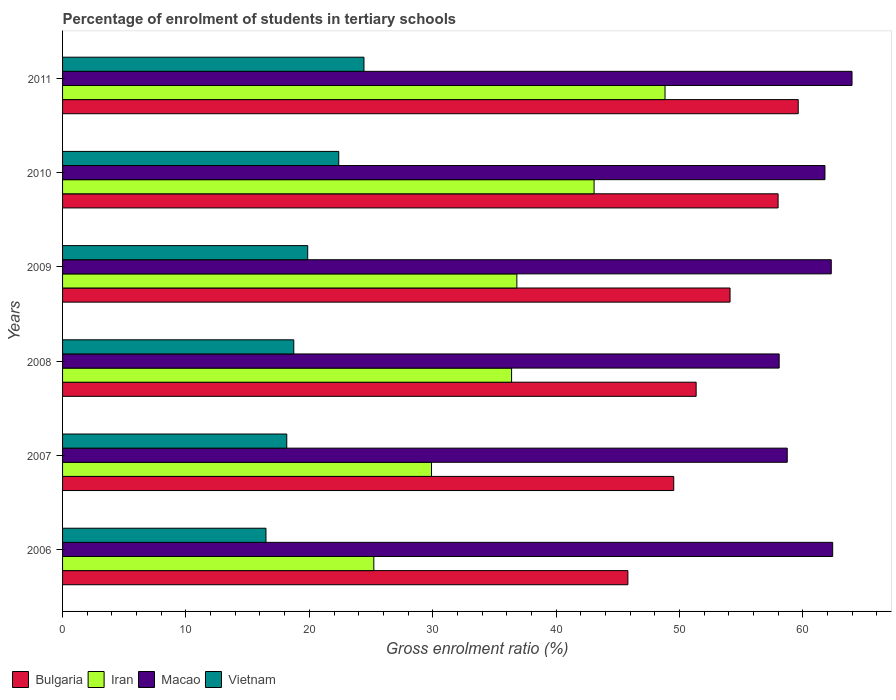How many groups of bars are there?
Provide a short and direct response. 6. Are the number of bars per tick equal to the number of legend labels?
Offer a terse response. Yes. Are the number of bars on each tick of the Y-axis equal?
Your answer should be very brief. Yes. What is the percentage of students enrolled in tertiary schools in Bulgaria in 2011?
Provide a succinct answer. 59.63. Across all years, what is the maximum percentage of students enrolled in tertiary schools in Macao?
Provide a short and direct response. 63.99. Across all years, what is the minimum percentage of students enrolled in tertiary schools in Vietnam?
Make the answer very short. 16.49. What is the total percentage of students enrolled in tertiary schools in Bulgaria in the graph?
Keep it short and to the point. 318.42. What is the difference between the percentage of students enrolled in tertiary schools in Bulgaria in 2006 and that in 2007?
Offer a very short reply. -3.72. What is the difference between the percentage of students enrolled in tertiary schools in Bulgaria in 2008 and the percentage of students enrolled in tertiary schools in Vietnam in 2007?
Your answer should be very brief. 33.18. What is the average percentage of students enrolled in tertiary schools in Bulgaria per year?
Your answer should be compact. 53.07. In the year 2011, what is the difference between the percentage of students enrolled in tertiary schools in Iran and percentage of students enrolled in tertiary schools in Bulgaria?
Ensure brevity in your answer.  -10.8. What is the ratio of the percentage of students enrolled in tertiary schools in Vietnam in 2010 to that in 2011?
Your answer should be very brief. 0.92. What is the difference between the highest and the second highest percentage of students enrolled in tertiary schools in Iran?
Ensure brevity in your answer.  5.75. What is the difference between the highest and the lowest percentage of students enrolled in tertiary schools in Bulgaria?
Offer a very short reply. 13.81. In how many years, is the percentage of students enrolled in tertiary schools in Macao greater than the average percentage of students enrolled in tertiary schools in Macao taken over all years?
Ensure brevity in your answer.  4. Is the sum of the percentage of students enrolled in tertiary schools in Iran in 2008 and 2010 greater than the maximum percentage of students enrolled in tertiary schools in Macao across all years?
Your answer should be very brief. Yes. Is it the case that in every year, the sum of the percentage of students enrolled in tertiary schools in Macao and percentage of students enrolled in tertiary schools in Iran is greater than the sum of percentage of students enrolled in tertiary schools in Vietnam and percentage of students enrolled in tertiary schools in Bulgaria?
Your response must be concise. No. What does the 2nd bar from the top in 2007 represents?
Your answer should be very brief. Macao. What does the 3rd bar from the bottom in 2009 represents?
Your answer should be very brief. Macao. Is it the case that in every year, the sum of the percentage of students enrolled in tertiary schools in Macao and percentage of students enrolled in tertiary schools in Iran is greater than the percentage of students enrolled in tertiary schools in Bulgaria?
Your response must be concise. Yes. Are the values on the major ticks of X-axis written in scientific E-notation?
Provide a succinct answer. No. Does the graph contain grids?
Your response must be concise. No. How many legend labels are there?
Make the answer very short. 4. What is the title of the graph?
Provide a succinct answer. Percentage of enrolment of students in tertiary schools. Does "North America" appear as one of the legend labels in the graph?
Give a very brief answer. No. What is the label or title of the X-axis?
Your response must be concise. Gross enrolment ratio (%). What is the Gross enrolment ratio (%) in Bulgaria in 2006?
Your response must be concise. 45.82. What is the Gross enrolment ratio (%) of Iran in 2006?
Give a very brief answer. 25.23. What is the Gross enrolment ratio (%) of Macao in 2006?
Your answer should be compact. 62.42. What is the Gross enrolment ratio (%) in Vietnam in 2006?
Your response must be concise. 16.49. What is the Gross enrolment ratio (%) in Bulgaria in 2007?
Ensure brevity in your answer.  49.53. What is the Gross enrolment ratio (%) of Iran in 2007?
Make the answer very short. 29.9. What is the Gross enrolment ratio (%) in Macao in 2007?
Your answer should be very brief. 58.73. What is the Gross enrolment ratio (%) of Vietnam in 2007?
Your response must be concise. 18.17. What is the Gross enrolment ratio (%) of Bulgaria in 2008?
Provide a succinct answer. 51.35. What is the Gross enrolment ratio (%) in Iran in 2008?
Offer a very short reply. 36.39. What is the Gross enrolment ratio (%) in Macao in 2008?
Your response must be concise. 58.08. What is the Gross enrolment ratio (%) in Vietnam in 2008?
Your answer should be very brief. 18.74. What is the Gross enrolment ratio (%) in Bulgaria in 2009?
Offer a very short reply. 54.1. What is the Gross enrolment ratio (%) in Iran in 2009?
Provide a short and direct response. 36.82. What is the Gross enrolment ratio (%) of Macao in 2009?
Your answer should be very brief. 62.3. What is the Gross enrolment ratio (%) in Vietnam in 2009?
Your answer should be very brief. 19.87. What is the Gross enrolment ratio (%) in Bulgaria in 2010?
Ensure brevity in your answer.  57.99. What is the Gross enrolment ratio (%) of Iran in 2010?
Make the answer very short. 43.08. What is the Gross enrolment ratio (%) in Macao in 2010?
Make the answer very short. 61.79. What is the Gross enrolment ratio (%) of Vietnam in 2010?
Offer a very short reply. 22.39. What is the Gross enrolment ratio (%) of Bulgaria in 2011?
Provide a short and direct response. 59.63. What is the Gross enrolment ratio (%) of Iran in 2011?
Your answer should be very brief. 48.83. What is the Gross enrolment ratio (%) of Macao in 2011?
Provide a succinct answer. 63.99. What is the Gross enrolment ratio (%) of Vietnam in 2011?
Your response must be concise. 24.43. Across all years, what is the maximum Gross enrolment ratio (%) in Bulgaria?
Offer a very short reply. 59.63. Across all years, what is the maximum Gross enrolment ratio (%) of Iran?
Offer a very short reply. 48.83. Across all years, what is the maximum Gross enrolment ratio (%) of Macao?
Offer a very short reply. 63.99. Across all years, what is the maximum Gross enrolment ratio (%) of Vietnam?
Provide a succinct answer. 24.43. Across all years, what is the minimum Gross enrolment ratio (%) of Bulgaria?
Your response must be concise. 45.82. Across all years, what is the minimum Gross enrolment ratio (%) of Iran?
Make the answer very short. 25.23. Across all years, what is the minimum Gross enrolment ratio (%) of Macao?
Give a very brief answer. 58.08. Across all years, what is the minimum Gross enrolment ratio (%) of Vietnam?
Provide a short and direct response. 16.49. What is the total Gross enrolment ratio (%) of Bulgaria in the graph?
Give a very brief answer. 318.42. What is the total Gross enrolment ratio (%) in Iran in the graph?
Keep it short and to the point. 220.26. What is the total Gross enrolment ratio (%) of Macao in the graph?
Give a very brief answer. 367.31. What is the total Gross enrolment ratio (%) of Vietnam in the graph?
Your answer should be compact. 120.08. What is the difference between the Gross enrolment ratio (%) in Bulgaria in 2006 and that in 2007?
Offer a terse response. -3.72. What is the difference between the Gross enrolment ratio (%) of Iran in 2006 and that in 2007?
Your answer should be very brief. -4.67. What is the difference between the Gross enrolment ratio (%) in Macao in 2006 and that in 2007?
Your response must be concise. 3.68. What is the difference between the Gross enrolment ratio (%) in Vietnam in 2006 and that in 2007?
Make the answer very short. -1.69. What is the difference between the Gross enrolment ratio (%) of Bulgaria in 2006 and that in 2008?
Keep it short and to the point. -5.53. What is the difference between the Gross enrolment ratio (%) in Iran in 2006 and that in 2008?
Offer a very short reply. -11.17. What is the difference between the Gross enrolment ratio (%) in Macao in 2006 and that in 2008?
Provide a short and direct response. 4.34. What is the difference between the Gross enrolment ratio (%) in Vietnam in 2006 and that in 2008?
Provide a succinct answer. -2.26. What is the difference between the Gross enrolment ratio (%) in Bulgaria in 2006 and that in 2009?
Provide a succinct answer. -8.28. What is the difference between the Gross enrolment ratio (%) of Iran in 2006 and that in 2009?
Offer a terse response. -11.59. What is the difference between the Gross enrolment ratio (%) in Macao in 2006 and that in 2009?
Ensure brevity in your answer.  0.11. What is the difference between the Gross enrolment ratio (%) of Vietnam in 2006 and that in 2009?
Provide a short and direct response. -3.38. What is the difference between the Gross enrolment ratio (%) in Bulgaria in 2006 and that in 2010?
Offer a very short reply. -12.17. What is the difference between the Gross enrolment ratio (%) of Iran in 2006 and that in 2010?
Ensure brevity in your answer.  -17.85. What is the difference between the Gross enrolment ratio (%) of Macao in 2006 and that in 2010?
Offer a very short reply. 0.63. What is the difference between the Gross enrolment ratio (%) of Vietnam in 2006 and that in 2010?
Your answer should be very brief. -5.9. What is the difference between the Gross enrolment ratio (%) in Bulgaria in 2006 and that in 2011?
Provide a short and direct response. -13.81. What is the difference between the Gross enrolment ratio (%) of Iran in 2006 and that in 2011?
Provide a succinct answer. -23.6. What is the difference between the Gross enrolment ratio (%) in Macao in 2006 and that in 2011?
Give a very brief answer. -1.57. What is the difference between the Gross enrolment ratio (%) of Vietnam in 2006 and that in 2011?
Offer a very short reply. -7.94. What is the difference between the Gross enrolment ratio (%) of Bulgaria in 2007 and that in 2008?
Offer a terse response. -1.82. What is the difference between the Gross enrolment ratio (%) of Iran in 2007 and that in 2008?
Ensure brevity in your answer.  -6.49. What is the difference between the Gross enrolment ratio (%) of Macao in 2007 and that in 2008?
Ensure brevity in your answer.  0.65. What is the difference between the Gross enrolment ratio (%) of Vietnam in 2007 and that in 2008?
Give a very brief answer. -0.57. What is the difference between the Gross enrolment ratio (%) of Bulgaria in 2007 and that in 2009?
Your response must be concise. -4.56. What is the difference between the Gross enrolment ratio (%) in Iran in 2007 and that in 2009?
Ensure brevity in your answer.  -6.92. What is the difference between the Gross enrolment ratio (%) of Macao in 2007 and that in 2009?
Offer a very short reply. -3.57. What is the difference between the Gross enrolment ratio (%) of Vietnam in 2007 and that in 2009?
Offer a terse response. -1.7. What is the difference between the Gross enrolment ratio (%) in Bulgaria in 2007 and that in 2010?
Offer a very short reply. -8.46. What is the difference between the Gross enrolment ratio (%) in Iran in 2007 and that in 2010?
Provide a succinct answer. -13.18. What is the difference between the Gross enrolment ratio (%) of Macao in 2007 and that in 2010?
Give a very brief answer. -3.06. What is the difference between the Gross enrolment ratio (%) in Vietnam in 2007 and that in 2010?
Keep it short and to the point. -4.21. What is the difference between the Gross enrolment ratio (%) of Bulgaria in 2007 and that in 2011?
Provide a short and direct response. -10.09. What is the difference between the Gross enrolment ratio (%) in Iran in 2007 and that in 2011?
Give a very brief answer. -18.93. What is the difference between the Gross enrolment ratio (%) of Macao in 2007 and that in 2011?
Provide a succinct answer. -5.25. What is the difference between the Gross enrolment ratio (%) of Vietnam in 2007 and that in 2011?
Make the answer very short. -6.26. What is the difference between the Gross enrolment ratio (%) of Bulgaria in 2008 and that in 2009?
Make the answer very short. -2.75. What is the difference between the Gross enrolment ratio (%) of Iran in 2008 and that in 2009?
Provide a succinct answer. -0.43. What is the difference between the Gross enrolment ratio (%) in Macao in 2008 and that in 2009?
Your answer should be very brief. -4.22. What is the difference between the Gross enrolment ratio (%) in Vietnam in 2008 and that in 2009?
Your answer should be very brief. -1.13. What is the difference between the Gross enrolment ratio (%) in Bulgaria in 2008 and that in 2010?
Provide a short and direct response. -6.64. What is the difference between the Gross enrolment ratio (%) in Iran in 2008 and that in 2010?
Provide a succinct answer. -6.69. What is the difference between the Gross enrolment ratio (%) of Macao in 2008 and that in 2010?
Your answer should be very brief. -3.71. What is the difference between the Gross enrolment ratio (%) of Vietnam in 2008 and that in 2010?
Make the answer very short. -3.64. What is the difference between the Gross enrolment ratio (%) of Bulgaria in 2008 and that in 2011?
Give a very brief answer. -8.27. What is the difference between the Gross enrolment ratio (%) in Iran in 2008 and that in 2011?
Give a very brief answer. -12.44. What is the difference between the Gross enrolment ratio (%) of Macao in 2008 and that in 2011?
Provide a short and direct response. -5.9. What is the difference between the Gross enrolment ratio (%) in Vietnam in 2008 and that in 2011?
Make the answer very short. -5.69. What is the difference between the Gross enrolment ratio (%) of Bulgaria in 2009 and that in 2010?
Provide a short and direct response. -3.89. What is the difference between the Gross enrolment ratio (%) in Iran in 2009 and that in 2010?
Your answer should be compact. -6.26. What is the difference between the Gross enrolment ratio (%) in Macao in 2009 and that in 2010?
Provide a succinct answer. 0.51. What is the difference between the Gross enrolment ratio (%) in Vietnam in 2009 and that in 2010?
Provide a succinct answer. -2.52. What is the difference between the Gross enrolment ratio (%) of Bulgaria in 2009 and that in 2011?
Offer a very short reply. -5.53. What is the difference between the Gross enrolment ratio (%) of Iran in 2009 and that in 2011?
Offer a terse response. -12.01. What is the difference between the Gross enrolment ratio (%) in Macao in 2009 and that in 2011?
Your answer should be compact. -1.68. What is the difference between the Gross enrolment ratio (%) of Vietnam in 2009 and that in 2011?
Keep it short and to the point. -4.56. What is the difference between the Gross enrolment ratio (%) of Bulgaria in 2010 and that in 2011?
Give a very brief answer. -1.63. What is the difference between the Gross enrolment ratio (%) of Iran in 2010 and that in 2011?
Offer a terse response. -5.75. What is the difference between the Gross enrolment ratio (%) in Macao in 2010 and that in 2011?
Your answer should be very brief. -2.19. What is the difference between the Gross enrolment ratio (%) of Vietnam in 2010 and that in 2011?
Ensure brevity in your answer.  -2.04. What is the difference between the Gross enrolment ratio (%) in Bulgaria in 2006 and the Gross enrolment ratio (%) in Iran in 2007?
Your answer should be very brief. 15.92. What is the difference between the Gross enrolment ratio (%) of Bulgaria in 2006 and the Gross enrolment ratio (%) of Macao in 2007?
Your answer should be very brief. -12.91. What is the difference between the Gross enrolment ratio (%) in Bulgaria in 2006 and the Gross enrolment ratio (%) in Vietnam in 2007?
Keep it short and to the point. 27.65. What is the difference between the Gross enrolment ratio (%) of Iran in 2006 and the Gross enrolment ratio (%) of Macao in 2007?
Ensure brevity in your answer.  -33.51. What is the difference between the Gross enrolment ratio (%) in Iran in 2006 and the Gross enrolment ratio (%) in Vietnam in 2007?
Provide a short and direct response. 7.06. What is the difference between the Gross enrolment ratio (%) in Macao in 2006 and the Gross enrolment ratio (%) in Vietnam in 2007?
Keep it short and to the point. 44.25. What is the difference between the Gross enrolment ratio (%) in Bulgaria in 2006 and the Gross enrolment ratio (%) in Iran in 2008?
Ensure brevity in your answer.  9.43. What is the difference between the Gross enrolment ratio (%) of Bulgaria in 2006 and the Gross enrolment ratio (%) of Macao in 2008?
Keep it short and to the point. -12.26. What is the difference between the Gross enrolment ratio (%) of Bulgaria in 2006 and the Gross enrolment ratio (%) of Vietnam in 2008?
Keep it short and to the point. 27.08. What is the difference between the Gross enrolment ratio (%) of Iran in 2006 and the Gross enrolment ratio (%) of Macao in 2008?
Provide a succinct answer. -32.85. What is the difference between the Gross enrolment ratio (%) of Iran in 2006 and the Gross enrolment ratio (%) of Vietnam in 2008?
Offer a very short reply. 6.49. What is the difference between the Gross enrolment ratio (%) in Macao in 2006 and the Gross enrolment ratio (%) in Vietnam in 2008?
Provide a succinct answer. 43.68. What is the difference between the Gross enrolment ratio (%) of Bulgaria in 2006 and the Gross enrolment ratio (%) of Iran in 2009?
Offer a terse response. 9. What is the difference between the Gross enrolment ratio (%) of Bulgaria in 2006 and the Gross enrolment ratio (%) of Macao in 2009?
Your answer should be very brief. -16.48. What is the difference between the Gross enrolment ratio (%) in Bulgaria in 2006 and the Gross enrolment ratio (%) in Vietnam in 2009?
Provide a succinct answer. 25.95. What is the difference between the Gross enrolment ratio (%) of Iran in 2006 and the Gross enrolment ratio (%) of Macao in 2009?
Keep it short and to the point. -37.07. What is the difference between the Gross enrolment ratio (%) of Iran in 2006 and the Gross enrolment ratio (%) of Vietnam in 2009?
Ensure brevity in your answer.  5.36. What is the difference between the Gross enrolment ratio (%) of Macao in 2006 and the Gross enrolment ratio (%) of Vietnam in 2009?
Ensure brevity in your answer.  42.55. What is the difference between the Gross enrolment ratio (%) of Bulgaria in 2006 and the Gross enrolment ratio (%) of Iran in 2010?
Your answer should be very brief. 2.74. What is the difference between the Gross enrolment ratio (%) of Bulgaria in 2006 and the Gross enrolment ratio (%) of Macao in 2010?
Your response must be concise. -15.97. What is the difference between the Gross enrolment ratio (%) of Bulgaria in 2006 and the Gross enrolment ratio (%) of Vietnam in 2010?
Ensure brevity in your answer.  23.43. What is the difference between the Gross enrolment ratio (%) in Iran in 2006 and the Gross enrolment ratio (%) in Macao in 2010?
Offer a very short reply. -36.56. What is the difference between the Gross enrolment ratio (%) of Iran in 2006 and the Gross enrolment ratio (%) of Vietnam in 2010?
Offer a terse response. 2.84. What is the difference between the Gross enrolment ratio (%) in Macao in 2006 and the Gross enrolment ratio (%) in Vietnam in 2010?
Provide a short and direct response. 40.03. What is the difference between the Gross enrolment ratio (%) in Bulgaria in 2006 and the Gross enrolment ratio (%) in Iran in 2011?
Ensure brevity in your answer.  -3.01. What is the difference between the Gross enrolment ratio (%) in Bulgaria in 2006 and the Gross enrolment ratio (%) in Macao in 2011?
Provide a succinct answer. -18.17. What is the difference between the Gross enrolment ratio (%) of Bulgaria in 2006 and the Gross enrolment ratio (%) of Vietnam in 2011?
Your answer should be compact. 21.39. What is the difference between the Gross enrolment ratio (%) of Iran in 2006 and the Gross enrolment ratio (%) of Macao in 2011?
Ensure brevity in your answer.  -38.76. What is the difference between the Gross enrolment ratio (%) in Iran in 2006 and the Gross enrolment ratio (%) in Vietnam in 2011?
Give a very brief answer. 0.8. What is the difference between the Gross enrolment ratio (%) of Macao in 2006 and the Gross enrolment ratio (%) of Vietnam in 2011?
Offer a very short reply. 37.99. What is the difference between the Gross enrolment ratio (%) of Bulgaria in 2007 and the Gross enrolment ratio (%) of Iran in 2008?
Provide a succinct answer. 13.14. What is the difference between the Gross enrolment ratio (%) of Bulgaria in 2007 and the Gross enrolment ratio (%) of Macao in 2008?
Keep it short and to the point. -8.55. What is the difference between the Gross enrolment ratio (%) of Bulgaria in 2007 and the Gross enrolment ratio (%) of Vietnam in 2008?
Your answer should be compact. 30.79. What is the difference between the Gross enrolment ratio (%) of Iran in 2007 and the Gross enrolment ratio (%) of Macao in 2008?
Ensure brevity in your answer.  -28.18. What is the difference between the Gross enrolment ratio (%) in Iran in 2007 and the Gross enrolment ratio (%) in Vietnam in 2008?
Offer a terse response. 11.16. What is the difference between the Gross enrolment ratio (%) of Macao in 2007 and the Gross enrolment ratio (%) of Vietnam in 2008?
Your answer should be very brief. 39.99. What is the difference between the Gross enrolment ratio (%) in Bulgaria in 2007 and the Gross enrolment ratio (%) in Iran in 2009?
Give a very brief answer. 12.71. What is the difference between the Gross enrolment ratio (%) in Bulgaria in 2007 and the Gross enrolment ratio (%) in Macao in 2009?
Keep it short and to the point. -12.77. What is the difference between the Gross enrolment ratio (%) in Bulgaria in 2007 and the Gross enrolment ratio (%) in Vietnam in 2009?
Offer a very short reply. 29.67. What is the difference between the Gross enrolment ratio (%) of Iran in 2007 and the Gross enrolment ratio (%) of Macao in 2009?
Provide a short and direct response. -32.4. What is the difference between the Gross enrolment ratio (%) in Iran in 2007 and the Gross enrolment ratio (%) in Vietnam in 2009?
Provide a short and direct response. 10.03. What is the difference between the Gross enrolment ratio (%) of Macao in 2007 and the Gross enrolment ratio (%) of Vietnam in 2009?
Provide a succinct answer. 38.87. What is the difference between the Gross enrolment ratio (%) in Bulgaria in 2007 and the Gross enrolment ratio (%) in Iran in 2010?
Provide a succinct answer. 6.45. What is the difference between the Gross enrolment ratio (%) of Bulgaria in 2007 and the Gross enrolment ratio (%) of Macao in 2010?
Your answer should be compact. -12.26. What is the difference between the Gross enrolment ratio (%) in Bulgaria in 2007 and the Gross enrolment ratio (%) in Vietnam in 2010?
Provide a succinct answer. 27.15. What is the difference between the Gross enrolment ratio (%) in Iran in 2007 and the Gross enrolment ratio (%) in Macao in 2010?
Your answer should be very brief. -31.89. What is the difference between the Gross enrolment ratio (%) in Iran in 2007 and the Gross enrolment ratio (%) in Vietnam in 2010?
Provide a short and direct response. 7.52. What is the difference between the Gross enrolment ratio (%) in Macao in 2007 and the Gross enrolment ratio (%) in Vietnam in 2010?
Offer a terse response. 36.35. What is the difference between the Gross enrolment ratio (%) of Bulgaria in 2007 and the Gross enrolment ratio (%) of Iran in 2011?
Offer a terse response. 0.71. What is the difference between the Gross enrolment ratio (%) of Bulgaria in 2007 and the Gross enrolment ratio (%) of Macao in 2011?
Offer a very short reply. -14.45. What is the difference between the Gross enrolment ratio (%) of Bulgaria in 2007 and the Gross enrolment ratio (%) of Vietnam in 2011?
Keep it short and to the point. 25.11. What is the difference between the Gross enrolment ratio (%) in Iran in 2007 and the Gross enrolment ratio (%) in Macao in 2011?
Ensure brevity in your answer.  -34.08. What is the difference between the Gross enrolment ratio (%) of Iran in 2007 and the Gross enrolment ratio (%) of Vietnam in 2011?
Keep it short and to the point. 5.47. What is the difference between the Gross enrolment ratio (%) in Macao in 2007 and the Gross enrolment ratio (%) in Vietnam in 2011?
Offer a terse response. 34.31. What is the difference between the Gross enrolment ratio (%) of Bulgaria in 2008 and the Gross enrolment ratio (%) of Iran in 2009?
Give a very brief answer. 14.53. What is the difference between the Gross enrolment ratio (%) in Bulgaria in 2008 and the Gross enrolment ratio (%) in Macao in 2009?
Provide a succinct answer. -10.95. What is the difference between the Gross enrolment ratio (%) of Bulgaria in 2008 and the Gross enrolment ratio (%) of Vietnam in 2009?
Ensure brevity in your answer.  31.48. What is the difference between the Gross enrolment ratio (%) in Iran in 2008 and the Gross enrolment ratio (%) in Macao in 2009?
Give a very brief answer. -25.91. What is the difference between the Gross enrolment ratio (%) of Iran in 2008 and the Gross enrolment ratio (%) of Vietnam in 2009?
Offer a terse response. 16.52. What is the difference between the Gross enrolment ratio (%) of Macao in 2008 and the Gross enrolment ratio (%) of Vietnam in 2009?
Your response must be concise. 38.21. What is the difference between the Gross enrolment ratio (%) in Bulgaria in 2008 and the Gross enrolment ratio (%) in Iran in 2010?
Offer a very short reply. 8.27. What is the difference between the Gross enrolment ratio (%) of Bulgaria in 2008 and the Gross enrolment ratio (%) of Macao in 2010?
Offer a very short reply. -10.44. What is the difference between the Gross enrolment ratio (%) in Bulgaria in 2008 and the Gross enrolment ratio (%) in Vietnam in 2010?
Your answer should be very brief. 28.97. What is the difference between the Gross enrolment ratio (%) in Iran in 2008 and the Gross enrolment ratio (%) in Macao in 2010?
Make the answer very short. -25.4. What is the difference between the Gross enrolment ratio (%) of Iran in 2008 and the Gross enrolment ratio (%) of Vietnam in 2010?
Your answer should be compact. 14.01. What is the difference between the Gross enrolment ratio (%) of Macao in 2008 and the Gross enrolment ratio (%) of Vietnam in 2010?
Your response must be concise. 35.7. What is the difference between the Gross enrolment ratio (%) of Bulgaria in 2008 and the Gross enrolment ratio (%) of Iran in 2011?
Ensure brevity in your answer.  2.52. What is the difference between the Gross enrolment ratio (%) of Bulgaria in 2008 and the Gross enrolment ratio (%) of Macao in 2011?
Your answer should be compact. -12.63. What is the difference between the Gross enrolment ratio (%) of Bulgaria in 2008 and the Gross enrolment ratio (%) of Vietnam in 2011?
Your answer should be very brief. 26.92. What is the difference between the Gross enrolment ratio (%) in Iran in 2008 and the Gross enrolment ratio (%) in Macao in 2011?
Offer a very short reply. -27.59. What is the difference between the Gross enrolment ratio (%) of Iran in 2008 and the Gross enrolment ratio (%) of Vietnam in 2011?
Give a very brief answer. 11.96. What is the difference between the Gross enrolment ratio (%) in Macao in 2008 and the Gross enrolment ratio (%) in Vietnam in 2011?
Your answer should be compact. 33.65. What is the difference between the Gross enrolment ratio (%) of Bulgaria in 2009 and the Gross enrolment ratio (%) of Iran in 2010?
Keep it short and to the point. 11.02. What is the difference between the Gross enrolment ratio (%) of Bulgaria in 2009 and the Gross enrolment ratio (%) of Macao in 2010?
Provide a short and direct response. -7.69. What is the difference between the Gross enrolment ratio (%) of Bulgaria in 2009 and the Gross enrolment ratio (%) of Vietnam in 2010?
Your response must be concise. 31.71. What is the difference between the Gross enrolment ratio (%) of Iran in 2009 and the Gross enrolment ratio (%) of Macao in 2010?
Your response must be concise. -24.97. What is the difference between the Gross enrolment ratio (%) of Iran in 2009 and the Gross enrolment ratio (%) of Vietnam in 2010?
Give a very brief answer. 14.44. What is the difference between the Gross enrolment ratio (%) of Macao in 2009 and the Gross enrolment ratio (%) of Vietnam in 2010?
Your answer should be compact. 39.92. What is the difference between the Gross enrolment ratio (%) in Bulgaria in 2009 and the Gross enrolment ratio (%) in Iran in 2011?
Offer a terse response. 5.27. What is the difference between the Gross enrolment ratio (%) of Bulgaria in 2009 and the Gross enrolment ratio (%) of Macao in 2011?
Your response must be concise. -9.89. What is the difference between the Gross enrolment ratio (%) in Bulgaria in 2009 and the Gross enrolment ratio (%) in Vietnam in 2011?
Offer a terse response. 29.67. What is the difference between the Gross enrolment ratio (%) of Iran in 2009 and the Gross enrolment ratio (%) of Macao in 2011?
Provide a succinct answer. -27.16. What is the difference between the Gross enrolment ratio (%) of Iran in 2009 and the Gross enrolment ratio (%) of Vietnam in 2011?
Offer a very short reply. 12.39. What is the difference between the Gross enrolment ratio (%) in Macao in 2009 and the Gross enrolment ratio (%) in Vietnam in 2011?
Ensure brevity in your answer.  37.87. What is the difference between the Gross enrolment ratio (%) of Bulgaria in 2010 and the Gross enrolment ratio (%) of Iran in 2011?
Make the answer very short. 9.16. What is the difference between the Gross enrolment ratio (%) in Bulgaria in 2010 and the Gross enrolment ratio (%) in Macao in 2011?
Provide a succinct answer. -5.99. What is the difference between the Gross enrolment ratio (%) in Bulgaria in 2010 and the Gross enrolment ratio (%) in Vietnam in 2011?
Your answer should be very brief. 33.56. What is the difference between the Gross enrolment ratio (%) in Iran in 2010 and the Gross enrolment ratio (%) in Macao in 2011?
Provide a short and direct response. -20.9. What is the difference between the Gross enrolment ratio (%) of Iran in 2010 and the Gross enrolment ratio (%) of Vietnam in 2011?
Provide a succinct answer. 18.65. What is the difference between the Gross enrolment ratio (%) of Macao in 2010 and the Gross enrolment ratio (%) of Vietnam in 2011?
Provide a short and direct response. 37.36. What is the average Gross enrolment ratio (%) of Bulgaria per year?
Your answer should be compact. 53.07. What is the average Gross enrolment ratio (%) in Iran per year?
Offer a terse response. 36.71. What is the average Gross enrolment ratio (%) in Macao per year?
Give a very brief answer. 61.22. What is the average Gross enrolment ratio (%) in Vietnam per year?
Keep it short and to the point. 20.01. In the year 2006, what is the difference between the Gross enrolment ratio (%) in Bulgaria and Gross enrolment ratio (%) in Iran?
Provide a short and direct response. 20.59. In the year 2006, what is the difference between the Gross enrolment ratio (%) in Bulgaria and Gross enrolment ratio (%) in Macao?
Offer a very short reply. -16.6. In the year 2006, what is the difference between the Gross enrolment ratio (%) in Bulgaria and Gross enrolment ratio (%) in Vietnam?
Your response must be concise. 29.33. In the year 2006, what is the difference between the Gross enrolment ratio (%) of Iran and Gross enrolment ratio (%) of Macao?
Ensure brevity in your answer.  -37.19. In the year 2006, what is the difference between the Gross enrolment ratio (%) in Iran and Gross enrolment ratio (%) in Vietnam?
Ensure brevity in your answer.  8.74. In the year 2006, what is the difference between the Gross enrolment ratio (%) in Macao and Gross enrolment ratio (%) in Vietnam?
Your answer should be very brief. 45.93. In the year 2007, what is the difference between the Gross enrolment ratio (%) in Bulgaria and Gross enrolment ratio (%) in Iran?
Your response must be concise. 19.63. In the year 2007, what is the difference between the Gross enrolment ratio (%) of Bulgaria and Gross enrolment ratio (%) of Macao?
Your response must be concise. -9.2. In the year 2007, what is the difference between the Gross enrolment ratio (%) of Bulgaria and Gross enrolment ratio (%) of Vietnam?
Your response must be concise. 31.36. In the year 2007, what is the difference between the Gross enrolment ratio (%) in Iran and Gross enrolment ratio (%) in Macao?
Keep it short and to the point. -28.83. In the year 2007, what is the difference between the Gross enrolment ratio (%) in Iran and Gross enrolment ratio (%) in Vietnam?
Give a very brief answer. 11.73. In the year 2007, what is the difference between the Gross enrolment ratio (%) in Macao and Gross enrolment ratio (%) in Vietnam?
Make the answer very short. 40.56. In the year 2008, what is the difference between the Gross enrolment ratio (%) of Bulgaria and Gross enrolment ratio (%) of Iran?
Offer a very short reply. 14.96. In the year 2008, what is the difference between the Gross enrolment ratio (%) of Bulgaria and Gross enrolment ratio (%) of Macao?
Provide a succinct answer. -6.73. In the year 2008, what is the difference between the Gross enrolment ratio (%) of Bulgaria and Gross enrolment ratio (%) of Vietnam?
Give a very brief answer. 32.61. In the year 2008, what is the difference between the Gross enrolment ratio (%) in Iran and Gross enrolment ratio (%) in Macao?
Offer a very short reply. -21.69. In the year 2008, what is the difference between the Gross enrolment ratio (%) in Iran and Gross enrolment ratio (%) in Vietnam?
Keep it short and to the point. 17.65. In the year 2008, what is the difference between the Gross enrolment ratio (%) of Macao and Gross enrolment ratio (%) of Vietnam?
Keep it short and to the point. 39.34. In the year 2009, what is the difference between the Gross enrolment ratio (%) of Bulgaria and Gross enrolment ratio (%) of Iran?
Keep it short and to the point. 17.28. In the year 2009, what is the difference between the Gross enrolment ratio (%) in Bulgaria and Gross enrolment ratio (%) in Macao?
Make the answer very short. -8.2. In the year 2009, what is the difference between the Gross enrolment ratio (%) in Bulgaria and Gross enrolment ratio (%) in Vietnam?
Your answer should be compact. 34.23. In the year 2009, what is the difference between the Gross enrolment ratio (%) of Iran and Gross enrolment ratio (%) of Macao?
Offer a terse response. -25.48. In the year 2009, what is the difference between the Gross enrolment ratio (%) of Iran and Gross enrolment ratio (%) of Vietnam?
Your response must be concise. 16.95. In the year 2009, what is the difference between the Gross enrolment ratio (%) of Macao and Gross enrolment ratio (%) of Vietnam?
Make the answer very short. 42.43. In the year 2010, what is the difference between the Gross enrolment ratio (%) in Bulgaria and Gross enrolment ratio (%) in Iran?
Your response must be concise. 14.91. In the year 2010, what is the difference between the Gross enrolment ratio (%) of Bulgaria and Gross enrolment ratio (%) of Macao?
Make the answer very short. -3.8. In the year 2010, what is the difference between the Gross enrolment ratio (%) in Bulgaria and Gross enrolment ratio (%) in Vietnam?
Offer a terse response. 35.61. In the year 2010, what is the difference between the Gross enrolment ratio (%) of Iran and Gross enrolment ratio (%) of Macao?
Make the answer very short. -18.71. In the year 2010, what is the difference between the Gross enrolment ratio (%) in Iran and Gross enrolment ratio (%) in Vietnam?
Give a very brief answer. 20.7. In the year 2010, what is the difference between the Gross enrolment ratio (%) in Macao and Gross enrolment ratio (%) in Vietnam?
Provide a succinct answer. 39.41. In the year 2011, what is the difference between the Gross enrolment ratio (%) in Bulgaria and Gross enrolment ratio (%) in Iran?
Make the answer very short. 10.8. In the year 2011, what is the difference between the Gross enrolment ratio (%) of Bulgaria and Gross enrolment ratio (%) of Macao?
Keep it short and to the point. -4.36. In the year 2011, what is the difference between the Gross enrolment ratio (%) of Bulgaria and Gross enrolment ratio (%) of Vietnam?
Provide a succinct answer. 35.2. In the year 2011, what is the difference between the Gross enrolment ratio (%) in Iran and Gross enrolment ratio (%) in Macao?
Ensure brevity in your answer.  -15.16. In the year 2011, what is the difference between the Gross enrolment ratio (%) in Iran and Gross enrolment ratio (%) in Vietnam?
Offer a very short reply. 24.4. In the year 2011, what is the difference between the Gross enrolment ratio (%) in Macao and Gross enrolment ratio (%) in Vietnam?
Provide a short and direct response. 39.56. What is the ratio of the Gross enrolment ratio (%) of Bulgaria in 2006 to that in 2007?
Provide a succinct answer. 0.93. What is the ratio of the Gross enrolment ratio (%) of Iran in 2006 to that in 2007?
Offer a terse response. 0.84. What is the ratio of the Gross enrolment ratio (%) in Macao in 2006 to that in 2007?
Your answer should be very brief. 1.06. What is the ratio of the Gross enrolment ratio (%) of Vietnam in 2006 to that in 2007?
Provide a succinct answer. 0.91. What is the ratio of the Gross enrolment ratio (%) in Bulgaria in 2006 to that in 2008?
Your answer should be compact. 0.89. What is the ratio of the Gross enrolment ratio (%) in Iran in 2006 to that in 2008?
Provide a short and direct response. 0.69. What is the ratio of the Gross enrolment ratio (%) of Macao in 2006 to that in 2008?
Your answer should be compact. 1.07. What is the ratio of the Gross enrolment ratio (%) in Vietnam in 2006 to that in 2008?
Your response must be concise. 0.88. What is the ratio of the Gross enrolment ratio (%) of Bulgaria in 2006 to that in 2009?
Provide a short and direct response. 0.85. What is the ratio of the Gross enrolment ratio (%) of Iran in 2006 to that in 2009?
Keep it short and to the point. 0.69. What is the ratio of the Gross enrolment ratio (%) in Vietnam in 2006 to that in 2009?
Provide a short and direct response. 0.83. What is the ratio of the Gross enrolment ratio (%) of Bulgaria in 2006 to that in 2010?
Your answer should be compact. 0.79. What is the ratio of the Gross enrolment ratio (%) in Iran in 2006 to that in 2010?
Your response must be concise. 0.59. What is the ratio of the Gross enrolment ratio (%) in Vietnam in 2006 to that in 2010?
Your answer should be compact. 0.74. What is the ratio of the Gross enrolment ratio (%) of Bulgaria in 2006 to that in 2011?
Your answer should be very brief. 0.77. What is the ratio of the Gross enrolment ratio (%) in Iran in 2006 to that in 2011?
Your answer should be compact. 0.52. What is the ratio of the Gross enrolment ratio (%) in Macao in 2006 to that in 2011?
Provide a short and direct response. 0.98. What is the ratio of the Gross enrolment ratio (%) of Vietnam in 2006 to that in 2011?
Your answer should be compact. 0.67. What is the ratio of the Gross enrolment ratio (%) of Bulgaria in 2007 to that in 2008?
Your answer should be very brief. 0.96. What is the ratio of the Gross enrolment ratio (%) of Iran in 2007 to that in 2008?
Offer a terse response. 0.82. What is the ratio of the Gross enrolment ratio (%) in Macao in 2007 to that in 2008?
Your answer should be compact. 1.01. What is the ratio of the Gross enrolment ratio (%) in Vietnam in 2007 to that in 2008?
Provide a succinct answer. 0.97. What is the ratio of the Gross enrolment ratio (%) of Bulgaria in 2007 to that in 2009?
Ensure brevity in your answer.  0.92. What is the ratio of the Gross enrolment ratio (%) of Iran in 2007 to that in 2009?
Your answer should be compact. 0.81. What is the ratio of the Gross enrolment ratio (%) in Macao in 2007 to that in 2009?
Keep it short and to the point. 0.94. What is the ratio of the Gross enrolment ratio (%) of Vietnam in 2007 to that in 2009?
Provide a succinct answer. 0.91. What is the ratio of the Gross enrolment ratio (%) of Bulgaria in 2007 to that in 2010?
Make the answer very short. 0.85. What is the ratio of the Gross enrolment ratio (%) of Iran in 2007 to that in 2010?
Make the answer very short. 0.69. What is the ratio of the Gross enrolment ratio (%) of Macao in 2007 to that in 2010?
Your answer should be very brief. 0.95. What is the ratio of the Gross enrolment ratio (%) in Vietnam in 2007 to that in 2010?
Provide a short and direct response. 0.81. What is the ratio of the Gross enrolment ratio (%) in Bulgaria in 2007 to that in 2011?
Give a very brief answer. 0.83. What is the ratio of the Gross enrolment ratio (%) in Iran in 2007 to that in 2011?
Your answer should be very brief. 0.61. What is the ratio of the Gross enrolment ratio (%) in Macao in 2007 to that in 2011?
Offer a very short reply. 0.92. What is the ratio of the Gross enrolment ratio (%) of Vietnam in 2007 to that in 2011?
Make the answer very short. 0.74. What is the ratio of the Gross enrolment ratio (%) of Bulgaria in 2008 to that in 2009?
Your answer should be very brief. 0.95. What is the ratio of the Gross enrolment ratio (%) of Iran in 2008 to that in 2009?
Ensure brevity in your answer.  0.99. What is the ratio of the Gross enrolment ratio (%) of Macao in 2008 to that in 2009?
Offer a very short reply. 0.93. What is the ratio of the Gross enrolment ratio (%) of Vietnam in 2008 to that in 2009?
Provide a short and direct response. 0.94. What is the ratio of the Gross enrolment ratio (%) in Bulgaria in 2008 to that in 2010?
Ensure brevity in your answer.  0.89. What is the ratio of the Gross enrolment ratio (%) of Iran in 2008 to that in 2010?
Offer a very short reply. 0.84. What is the ratio of the Gross enrolment ratio (%) of Macao in 2008 to that in 2010?
Ensure brevity in your answer.  0.94. What is the ratio of the Gross enrolment ratio (%) in Vietnam in 2008 to that in 2010?
Provide a succinct answer. 0.84. What is the ratio of the Gross enrolment ratio (%) of Bulgaria in 2008 to that in 2011?
Offer a terse response. 0.86. What is the ratio of the Gross enrolment ratio (%) of Iran in 2008 to that in 2011?
Keep it short and to the point. 0.75. What is the ratio of the Gross enrolment ratio (%) of Macao in 2008 to that in 2011?
Provide a short and direct response. 0.91. What is the ratio of the Gross enrolment ratio (%) of Vietnam in 2008 to that in 2011?
Provide a short and direct response. 0.77. What is the ratio of the Gross enrolment ratio (%) in Bulgaria in 2009 to that in 2010?
Give a very brief answer. 0.93. What is the ratio of the Gross enrolment ratio (%) of Iran in 2009 to that in 2010?
Your response must be concise. 0.85. What is the ratio of the Gross enrolment ratio (%) in Macao in 2009 to that in 2010?
Give a very brief answer. 1.01. What is the ratio of the Gross enrolment ratio (%) in Vietnam in 2009 to that in 2010?
Your answer should be very brief. 0.89. What is the ratio of the Gross enrolment ratio (%) of Bulgaria in 2009 to that in 2011?
Provide a succinct answer. 0.91. What is the ratio of the Gross enrolment ratio (%) of Iran in 2009 to that in 2011?
Give a very brief answer. 0.75. What is the ratio of the Gross enrolment ratio (%) in Macao in 2009 to that in 2011?
Offer a terse response. 0.97. What is the ratio of the Gross enrolment ratio (%) in Vietnam in 2009 to that in 2011?
Offer a terse response. 0.81. What is the ratio of the Gross enrolment ratio (%) in Bulgaria in 2010 to that in 2011?
Ensure brevity in your answer.  0.97. What is the ratio of the Gross enrolment ratio (%) of Iran in 2010 to that in 2011?
Keep it short and to the point. 0.88. What is the ratio of the Gross enrolment ratio (%) of Macao in 2010 to that in 2011?
Provide a succinct answer. 0.97. What is the ratio of the Gross enrolment ratio (%) of Vietnam in 2010 to that in 2011?
Offer a very short reply. 0.92. What is the difference between the highest and the second highest Gross enrolment ratio (%) in Bulgaria?
Your answer should be very brief. 1.63. What is the difference between the highest and the second highest Gross enrolment ratio (%) in Iran?
Your response must be concise. 5.75. What is the difference between the highest and the second highest Gross enrolment ratio (%) of Macao?
Your answer should be very brief. 1.57. What is the difference between the highest and the second highest Gross enrolment ratio (%) of Vietnam?
Give a very brief answer. 2.04. What is the difference between the highest and the lowest Gross enrolment ratio (%) in Bulgaria?
Your answer should be compact. 13.81. What is the difference between the highest and the lowest Gross enrolment ratio (%) in Iran?
Provide a short and direct response. 23.6. What is the difference between the highest and the lowest Gross enrolment ratio (%) of Macao?
Your answer should be compact. 5.9. What is the difference between the highest and the lowest Gross enrolment ratio (%) in Vietnam?
Your answer should be very brief. 7.94. 